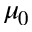<formula> <loc_0><loc_0><loc_500><loc_500>\mu _ { 0 }</formula> 